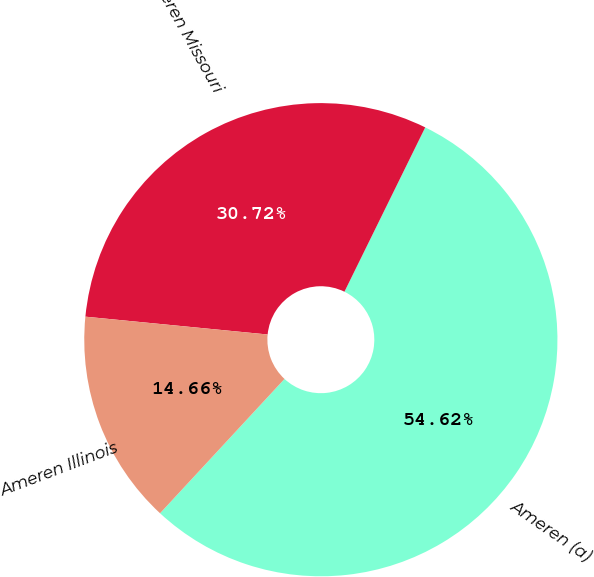<chart> <loc_0><loc_0><loc_500><loc_500><pie_chart><fcel>Ameren (a)<fcel>Ameren Missouri<fcel>Ameren Illinois<nl><fcel>54.62%<fcel>30.72%<fcel>14.66%<nl></chart> 